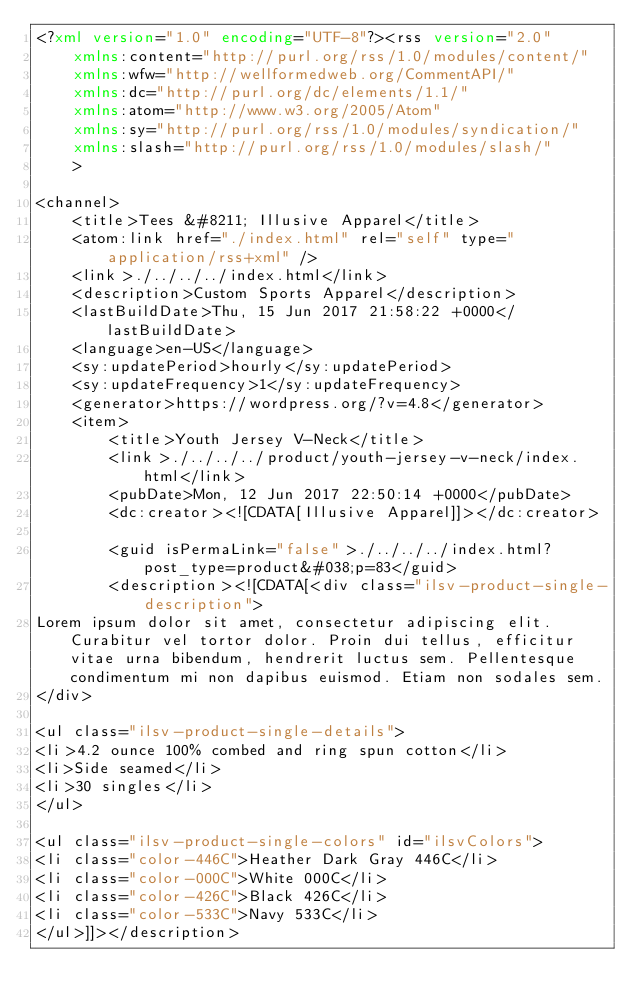<code> <loc_0><loc_0><loc_500><loc_500><_XML_><?xml version="1.0" encoding="UTF-8"?><rss version="2.0"
	xmlns:content="http://purl.org/rss/1.0/modules/content/"
	xmlns:wfw="http://wellformedweb.org/CommentAPI/"
	xmlns:dc="http://purl.org/dc/elements/1.1/"
	xmlns:atom="http://www.w3.org/2005/Atom"
	xmlns:sy="http://purl.org/rss/1.0/modules/syndication/"
	xmlns:slash="http://purl.org/rss/1.0/modules/slash/"
	>

<channel>
	<title>Tees &#8211; Illusive Apparel</title>
	<atom:link href="./index.html" rel="self" type="application/rss+xml" />
	<link>./../../../index.html</link>
	<description>Custom Sports Apparel</description>
	<lastBuildDate>Thu, 15 Jun 2017 21:58:22 +0000</lastBuildDate>
	<language>en-US</language>
	<sy:updatePeriod>hourly</sy:updatePeriod>
	<sy:updateFrequency>1</sy:updateFrequency>
	<generator>https://wordpress.org/?v=4.8</generator>
	<item>
		<title>Youth Jersey V-Neck</title>
		<link>./../../../product/youth-jersey-v-neck/index.html</link>
		<pubDate>Mon, 12 Jun 2017 22:50:14 +0000</pubDate>
		<dc:creator><![CDATA[Illusive Apparel]]></dc:creator>
		
		<guid isPermaLink="false">./../../../index.html?post_type=product&#038;p=83</guid>
		<description><![CDATA[<div class="ilsv-product-single-description">
Lorem ipsum dolor sit amet, consectetur adipiscing elit. Curabitur vel tortor dolor. Proin dui tellus, efficitur vitae urna bibendum, hendrerit luctus sem. Pellentesque condimentum mi non dapibus euismod. Etiam non sodales sem.
</div>

<ul class="ilsv-product-single-details">
<li>4.2 ounce 100% combed and ring spun cotton</li>
<li>Side seamed</li>
<li>30 singles</li>
</ul>

<ul class="ilsv-product-single-colors" id="ilsvColors">
<li class="color-446C">Heather Dark Gray 446C</li>
<li class="color-000C">White 000C</li>
<li class="color-426C">Black 426C</li>
<li class="color-533C">Navy 533C</li>
</ul>]]></description></code> 